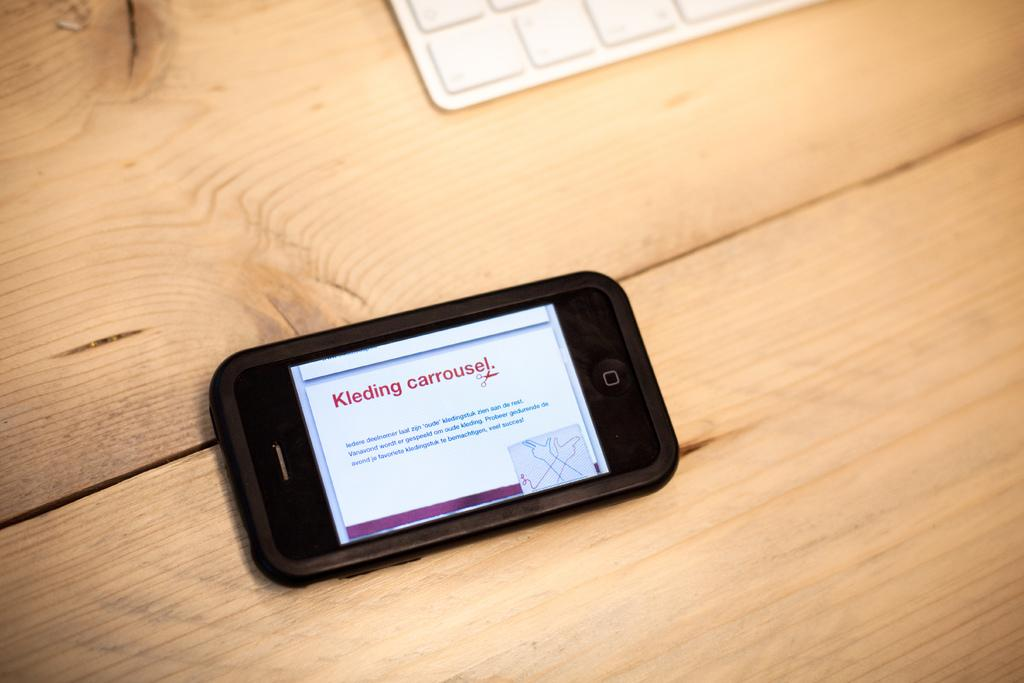<image>
Render a clear and concise summary of the photo. The phone on the table has the words kleding Carrousel on the screen. 